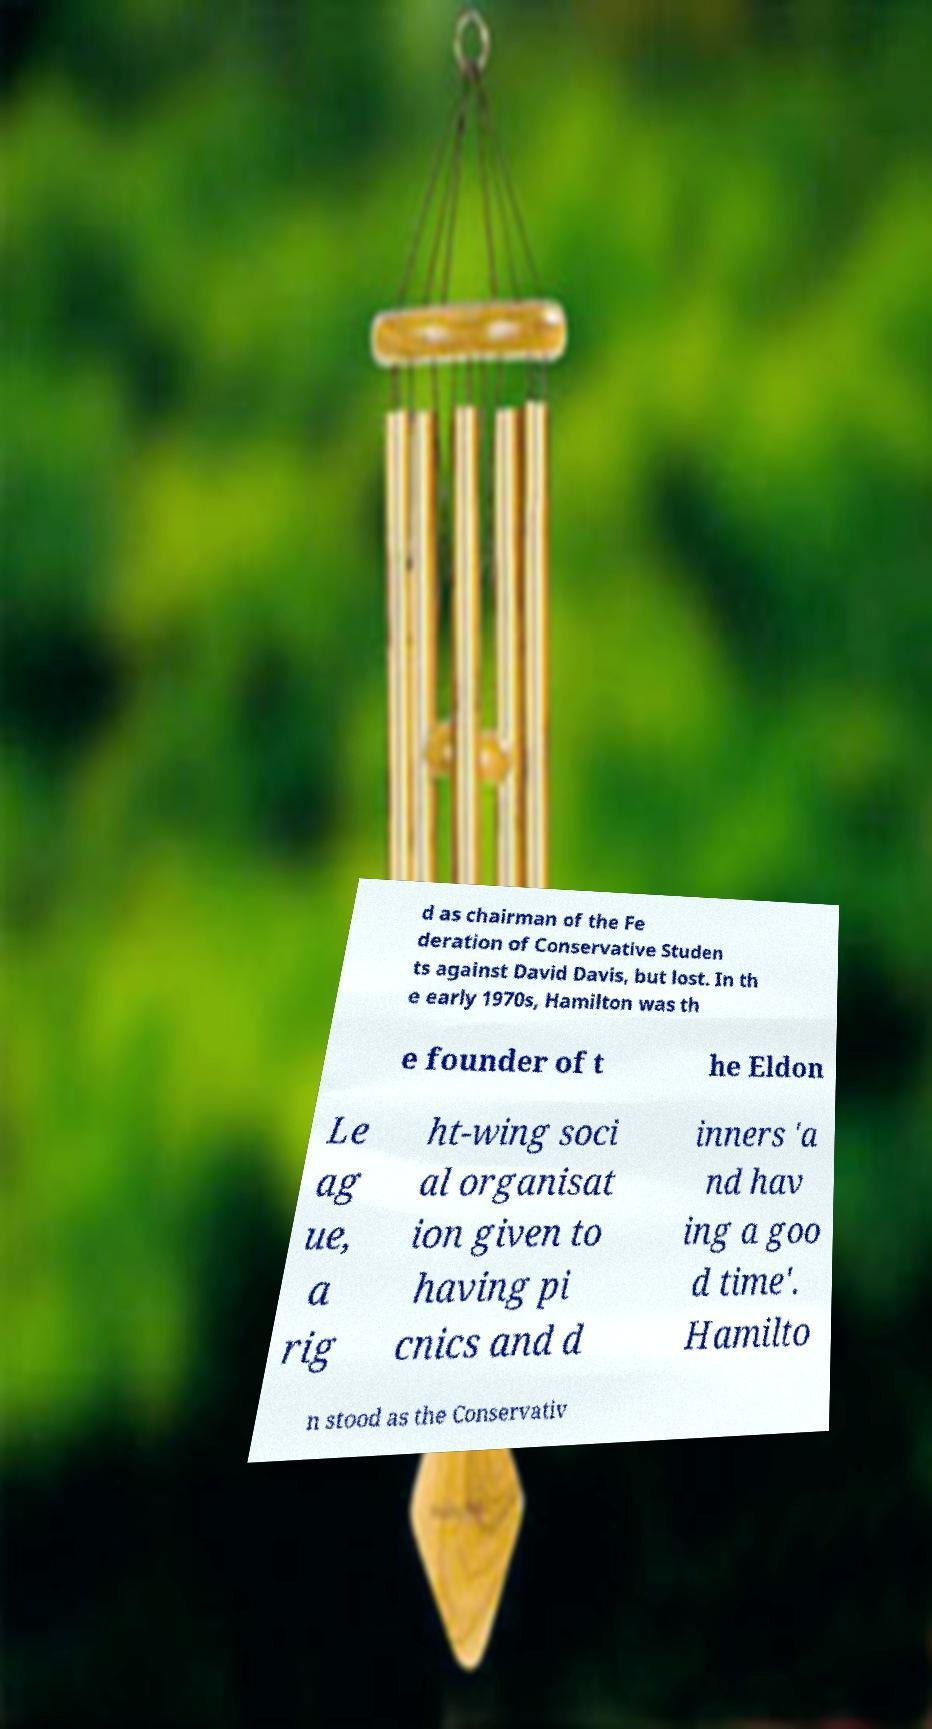What messages or text are displayed in this image? I need them in a readable, typed format. d as chairman of the Fe deration of Conservative Studen ts against David Davis, but lost. In th e early 1970s, Hamilton was th e founder of t he Eldon Le ag ue, a rig ht-wing soci al organisat ion given to having pi cnics and d inners 'a nd hav ing a goo d time'. Hamilto n stood as the Conservativ 